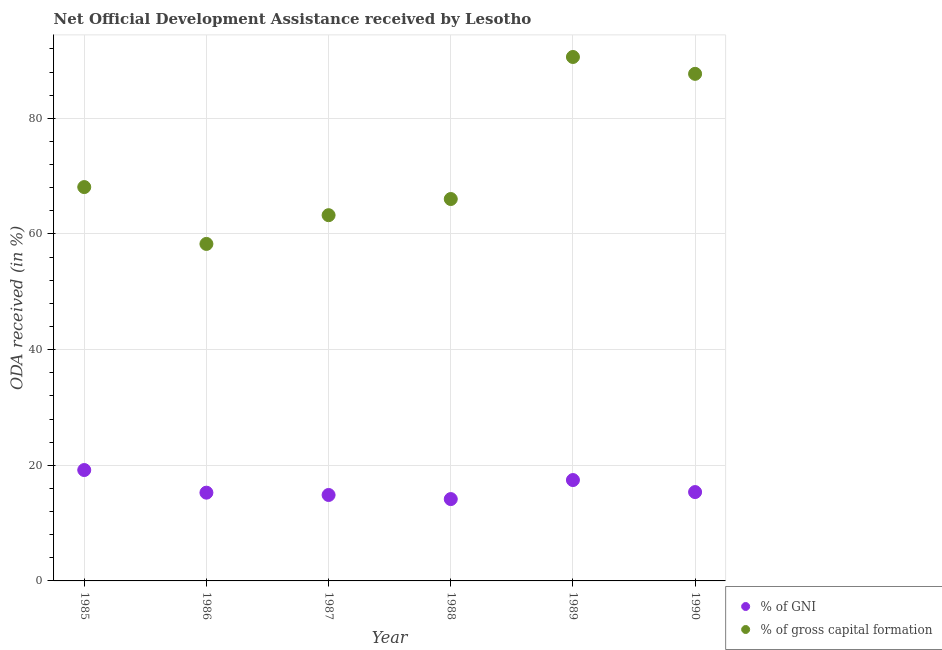How many different coloured dotlines are there?
Your answer should be very brief. 2. Is the number of dotlines equal to the number of legend labels?
Provide a short and direct response. Yes. What is the oda received as percentage of gni in 1989?
Ensure brevity in your answer.  17.44. Across all years, what is the maximum oda received as percentage of gni?
Ensure brevity in your answer.  19.18. Across all years, what is the minimum oda received as percentage of gni?
Ensure brevity in your answer.  14.15. In which year was the oda received as percentage of gni maximum?
Offer a very short reply. 1985. In which year was the oda received as percentage of gni minimum?
Provide a short and direct response. 1988. What is the total oda received as percentage of gross capital formation in the graph?
Your answer should be compact. 433.98. What is the difference between the oda received as percentage of gni in 1986 and that in 1990?
Provide a succinct answer. -0.1. What is the difference between the oda received as percentage of gross capital formation in 1985 and the oda received as percentage of gni in 1990?
Your answer should be compact. 52.74. What is the average oda received as percentage of gross capital formation per year?
Keep it short and to the point. 72.33. In the year 1986, what is the difference between the oda received as percentage of gross capital formation and oda received as percentage of gni?
Offer a very short reply. 43.02. In how many years, is the oda received as percentage of gni greater than 72 %?
Offer a terse response. 0. What is the ratio of the oda received as percentage of gross capital formation in 1987 to that in 1990?
Your answer should be very brief. 0.72. Is the oda received as percentage of gross capital formation in 1987 less than that in 1989?
Your response must be concise. Yes. Is the difference between the oda received as percentage of gross capital formation in 1988 and 1990 greater than the difference between the oda received as percentage of gni in 1988 and 1990?
Your answer should be compact. No. What is the difference between the highest and the second highest oda received as percentage of gross capital formation?
Offer a very short reply. 2.92. What is the difference between the highest and the lowest oda received as percentage of gross capital formation?
Offer a very short reply. 32.33. Is the sum of the oda received as percentage of gni in 1987 and 1988 greater than the maximum oda received as percentage of gross capital formation across all years?
Give a very brief answer. No. Is the oda received as percentage of gross capital formation strictly greater than the oda received as percentage of gni over the years?
Offer a terse response. Yes. How many years are there in the graph?
Your answer should be compact. 6. Are the values on the major ticks of Y-axis written in scientific E-notation?
Make the answer very short. No. How many legend labels are there?
Your response must be concise. 2. How are the legend labels stacked?
Your answer should be compact. Vertical. What is the title of the graph?
Offer a terse response. Net Official Development Assistance received by Lesotho. What is the label or title of the X-axis?
Provide a succinct answer. Year. What is the label or title of the Y-axis?
Your response must be concise. ODA received (in %). What is the ODA received (in %) of % of GNI in 1985?
Make the answer very short. 19.18. What is the ODA received (in %) of % of gross capital formation in 1985?
Offer a very short reply. 68.11. What is the ODA received (in %) of % of GNI in 1986?
Your response must be concise. 15.26. What is the ODA received (in %) of % of gross capital formation in 1986?
Your answer should be compact. 58.28. What is the ODA received (in %) of % of GNI in 1987?
Make the answer very short. 14.86. What is the ODA received (in %) in % of gross capital formation in 1987?
Provide a succinct answer. 63.25. What is the ODA received (in %) in % of GNI in 1988?
Your answer should be compact. 14.15. What is the ODA received (in %) in % of gross capital formation in 1988?
Ensure brevity in your answer.  66.04. What is the ODA received (in %) of % of GNI in 1989?
Keep it short and to the point. 17.44. What is the ODA received (in %) of % of gross capital formation in 1989?
Your answer should be very brief. 90.61. What is the ODA received (in %) of % of GNI in 1990?
Give a very brief answer. 15.37. What is the ODA received (in %) of % of gross capital formation in 1990?
Offer a terse response. 87.69. Across all years, what is the maximum ODA received (in %) in % of GNI?
Provide a short and direct response. 19.18. Across all years, what is the maximum ODA received (in %) in % of gross capital formation?
Ensure brevity in your answer.  90.61. Across all years, what is the minimum ODA received (in %) of % of GNI?
Provide a short and direct response. 14.15. Across all years, what is the minimum ODA received (in %) in % of gross capital formation?
Offer a very short reply. 58.28. What is the total ODA received (in %) of % of GNI in the graph?
Make the answer very short. 96.26. What is the total ODA received (in %) in % of gross capital formation in the graph?
Your response must be concise. 433.98. What is the difference between the ODA received (in %) in % of GNI in 1985 and that in 1986?
Ensure brevity in your answer.  3.91. What is the difference between the ODA received (in %) in % of gross capital formation in 1985 and that in 1986?
Provide a succinct answer. 9.83. What is the difference between the ODA received (in %) of % of GNI in 1985 and that in 1987?
Offer a very short reply. 4.32. What is the difference between the ODA received (in %) of % of gross capital formation in 1985 and that in 1987?
Offer a terse response. 4.86. What is the difference between the ODA received (in %) in % of GNI in 1985 and that in 1988?
Make the answer very short. 5.02. What is the difference between the ODA received (in %) in % of gross capital formation in 1985 and that in 1988?
Provide a short and direct response. 2.07. What is the difference between the ODA received (in %) in % of GNI in 1985 and that in 1989?
Provide a short and direct response. 1.73. What is the difference between the ODA received (in %) of % of gross capital formation in 1985 and that in 1989?
Your response must be concise. -22.5. What is the difference between the ODA received (in %) of % of GNI in 1985 and that in 1990?
Your answer should be very brief. 3.81. What is the difference between the ODA received (in %) of % of gross capital formation in 1985 and that in 1990?
Provide a succinct answer. -19.58. What is the difference between the ODA received (in %) in % of GNI in 1986 and that in 1987?
Keep it short and to the point. 0.4. What is the difference between the ODA received (in %) of % of gross capital formation in 1986 and that in 1987?
Give a very brief answer. -4.97. What is the difference between the ODA received (in %) of % of GNI in 1986 and that in 1988?
Ensure brevity in your answer.  1.11. What is the difference between the ODA received (in %) in % of gross capital formation in 1986 and that in 1988?
Your answer should be very brief. -7.77. What is the difference between the ODA received (in %) in % of GNI in 1986 and that in 1989?
Your answer should be very brief. -2.18. What is the difference between the ODA received (in %) in % of gross capital formation in 1986 and that in 1989?
Make the answer very short. -32.33. What is the difference between the ODA received (in %) in % of GNI in 1986 and that in 1990?
Offer a terse response. -0.1. What is the difference between the ODA received (in %) in % of gross capital formation in 1986 and that in 1990?
Give a very brief answer. -29.41. What is the difference between the ODA received (in %) of % of GNI in 1987 and that in 1988?
Offer a very short reply. 0.71. What is the difference between the ODA received (in %) of % of gross capital formation in 1987 and that in 1988?
Offer a very short reply. -2.8. What is the difference between the ODA received (in %) of % of GNI in 1987 and that in 1989?
Your response must be concise. -2.58. What is the difference between the ODA received (in %) of % of gross capital formation in 1987 and that in 1989?
Offer a very short reply. -27.36. What is the difference between the ODA received (in %) of % of GNI in 1987 and that in 1990?
Offer a very short reply. -0.5. What is the difference between the ODA received (in %) in % of gross capital formation in 1987 and that in 1990?
Provide a succinct answer. -24.44. What is the difference between the ODA received (in %) in % of GNI in 1988 and that in 1989?
Keep it short and to the point. -3.29. What is the difference between the ODA received (in %) in % of gross capital formation in 1988 and that in 1989?
Provide a succinct answer. -24.56. What is the difference between the ODA received (in %) of % of GNI in 1988 and that in 1990?
Give a very brief answer. -1.21. What is the difference between the ODA received (in %) in % of gross capital formation in 1988 and that in 1990?
Your answer should be very brief. -21.65. What is the difference between the ODA received (in %) of % of GNI in 1989 and that in 1990?
Give a very brief answer. 2.08. What is the difference between the ODA received (in %) in % of gross capital formation in 1989 and that in 1990?
Offer a terse response. 2.92. What is the difference between the ODA received (in %) of % of GNI in 1985 and the ODA received (in %) of % of gross capital formation in 1986?
Your response must be concise. -39.1. What is the difference between the ODA received (in %) in % of GNI in 1985 and the ODA received (in %) in % of gross capital formation in 1987?
Offer a very short reply. -44.07. What is the difference between the ODA received (in %) of % of GNI in 1985 and the ODA received (in %) of % of gross capital formation in 1988?
Offer a very short reply. -46.87. What is the difference between the ODA received (in %) of % of GNI in 1985 and the ODA received (in %) of % of gross capital formation in 1989?
Provide a short and direct response. -71.43. What is the difference between the ODA received (in %) in % of GNI in 1985 and the ODA received (in %) in % of gross capital formation in 1990?
Your response must be concise. -68.51. What is the difference between the ODA received (in %) of % of GNI in 1986 and the ODA received (in %) of % of gross capital formation in 1987?
Offer a very short reply. -47.99. What is the difference between the ODA received (in %) in % of GNI in 1986 and the ODA received (in %) in % of gross capital formation in 1988?
Offer a terse response. -50.78. What is the difference between the ODA received (in %) of % of GNI in 1986 and the ODA received (in %) of % of gross capital formation in 1989?
Your response must be concise. -75.34. What is the difference between the ODA received (in %) of % of GNI in 1986 and the ODA received (in %) of % of gross capital formation in 1990?
Your answer should be very brief. -72.43. What is the difference between the ODA received (in %) in % of GNI in 1987 and the ODA received (in %) in % of gross capital formation in 1988?
Offer a very short reply. -51.18. What is the difference between the ODA received (in %) in % of GNI in 1987 and the ODA received (in %) in % of gross capital formation in 1989?
Provide a short and direct response. -75.75. What is the difference between the ODA received (in %) of % of GNI in 1987 and the ODA received (in %) of % of gross capital formation in 1990?
Make the answer very short. -72.83. What is the difference between the ODA received (in %) of % of GNI in 1988 and the ODA received (in %) of % of gross capital formation in 1989?
Offer a very short reply. -76.45. What is the difference between the ODA received (in %) in % of GNI in 1988 and the ODA received (in %) in % of gross capital formation in 1990?
Provide a short and direct response. -73.54. What is the difference between the ODA received (in %) of % of GNI in 1989 and the ODA received (in %) of % of gross capital formation in 1990?
Your answer should be very brief. -70.25. What is the average ODA received (in %) of % of GNI per year?
Your response must be concise. 16.04. What is the average ODA received (in %) in % of gross capital formation per year?
Provide a short and direct response. 72.33. In the year 1985, what is the difference between the ODA received (in %) in % of GNI and ODA received (in %) in % of gross capital formation?
Offer a very short reply. -48.93. In the year 1986, what is the difference between the ODA received (in %) of % of GNI and ODA received (in %) of % of gross capital formation?
Ensure brevity in your answer.  -43.02. In the year 1987, what is the difference between the ODA received (in %) of % of GNI and ODA received (in %) of % of gross capital formation?
Offer a very short reply. -48.39. In the year 1988, what is the difference between the ODA received (in %) of % of GNI and ODA received (in %) of % of gross capital formation?
Your response must be concise. -51.89. In the year 1989, what is the difference between the ODA received (in %) in % of GNI and ODA received (in %) in % of gross capital formation?
Ensure brevity in your answer.  -73.16. In the year 1990, what is the difference between the ODA received (in %) in % of GNI and ODA received (in %) in % of gross capital formation?
Offer a very short reply. -72.32. What is the ratio of the ODA received (in %) of % of GNI in 1985 to that in 1986?
Give a very brief answer. 1.26. What is the ratio of the ODA received (in %) in % of gross capital formation in 1985 to that in 1986?
Your answer should be compact. 1.17. What is the ratio of the ODA received (in %) in % of GNI in 1985 to that in 1987?
Your response must be concise. 1.29. What is the ratio of the ODA received (in %) in % of GNI in 1985 to that in 1988?
Make the answer very short. 1.35. What is the ratio of the ODA received (in %) in % of gross capital formation in 1985 to that in 1988?
Your answer should be compact. 1.03. What is the ratio of the ODA received (in %) of % of GNI in 1985 to that in 1989?
Your response must be concise. 1.1. What is the ratio of the ODA received (in %) in % of gross capital formation in 1985 to that in 1989?
Provide a succinct answer. 0.75. What is the ratio of the ODA received (in %) in % of GNI in 1985 to that in 1990?
Ensure brevity in your answer.  1.25. What is the ratio of the ODA received (in %) of % of gross capital formation in 1985 to that in 1990?
Provide a succinct answer. 0.78. What is the ratio of the ODA received (in %) in % of GNI in 1986 to that in 1987?
Your answer should be compact. 1.03. What is the ratio of the ODA received (in %) in % of gross capital formation in 1986 to that in 1987?
Your response must be concise. 0.92. What is the ratio of the ODA received (in %) in % of GNI in 1986 to that in 1988?
Give a very brief answer. 1.08. What is the ratio of the ODA received (in %) in % of gross capital formation in 1986 to that in 1988?
Give a very brief answer. 0.88. What is the ratio of the ODA received (in %) of % of GNI in 1986 to that in 1989?
Keep it short and to the point. 0.88. What is the ratio of the ODA received (in %) in % of gross capital formation in 1986 to that in 1989?
Provide a succinct answer. 0.64. What is the ratio of the ODA received (in %) of % of GNI in 1986 to that in 1990?
Offer a very short reply. 0.99. What is the ratio of the ODA received (in %) of % of gross capital formation in 1986 to that in 1990?
Give a very brief answer. 0.66. What is the ratio of the ODA received (in %) of % of GNI in 1987 to that in 1988?
Your answer should be very brief. 1.05. What is the ratio of the ODA received (in %) in % of gross capital formation in 1987 to that in 1988?
Make the answer very short. 0.96. What is the ratio of the ODA received (in %) of % of GNI in 1987 to that in 1989?
Make the answer very short. 0.85. What is the ratio of the ODA received (in %) in % of gross capital formation in 1987 to that in 1989?
Your answer should be very brief. 0.7. What is the ratio of the ODA received (in %) in % of GNI in 1987 to that in 1990?
Ensure brevity in your answer.  0.97. What is the ratio of the ODA received (in %) in % of gross capital formation in 1987 to that in 1990?
Your answer should be very brief. 0.72. What is the ratio of the ODA received (in %) in % of GNI in 1988 to that in 1989?
Provide a short and direct response. 0.81. What is the ratio of the ODA received (in %) in % of gross capital formation in 1988 to that in 1989?
Provide a succinct answer. 0.73. What is the ratio of the ODA received (in %) of % of GNI in 1988 to that in 1990?
Give a very brief answer. 0.92. What is the ratio of the ODA received (in %) of % of gross capital formation in 1988 to that in 1990?
Offer a terse response. 0.75. What is the ratio of the ODA received (in %) of % of GNI in 1989 to that in 1990?
Keep it short and to the point. 1.14. What is the difference between the highest and the second highest ODA received (in %) in % of GNI?
Your answer should be very brief. 1.73. What is the difference between the highest and the second highest ODA received (in %) of % of gross capital formation?
Give a very brief answer. 2.92. What is the difference between the highest and the lowest ODA received (in %) in % of GNI?
Provide a succinct answer. 5.02. What is the difference between the highest and the lowest ODA received (in %) of % of gross capital formation?
Give a very brief answer. 32.33. 